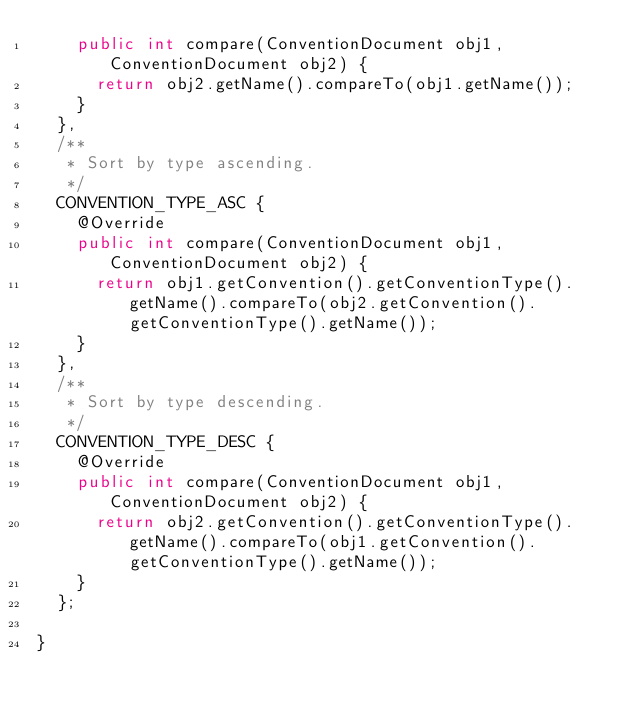<code> <loc_0><loc_0><loc_500><loc_500><_Java_>    public int compare(ConventionDocument obj1, ConventionDocument obj2) {
      return obj2.getName().compareTo(obj1.getName());
    }
  },
  /**
   * Sort by type ascending.
   */
  CONVENTION_TYPE_ASC {
    @Override
    public int compare(ConventionDocument obj1, ConventionDocument obj2) {
      return obj1.getConvention().getConventionType().getName().compareTo(obj2.getConvention().getConventionType().getName());
    }
  },
  /**
   * Sort by type descending.
   */
  CONVENTION_TYPE_DESC {
    @Override
    public int compare(ConventionDocument obj1, ConventionDocument obj2) {
      return obj2.getConvention().getConventionType().getName().compareTo(obj1.getConvention().getConventionType().getName());
    }
  };

}
</code> 